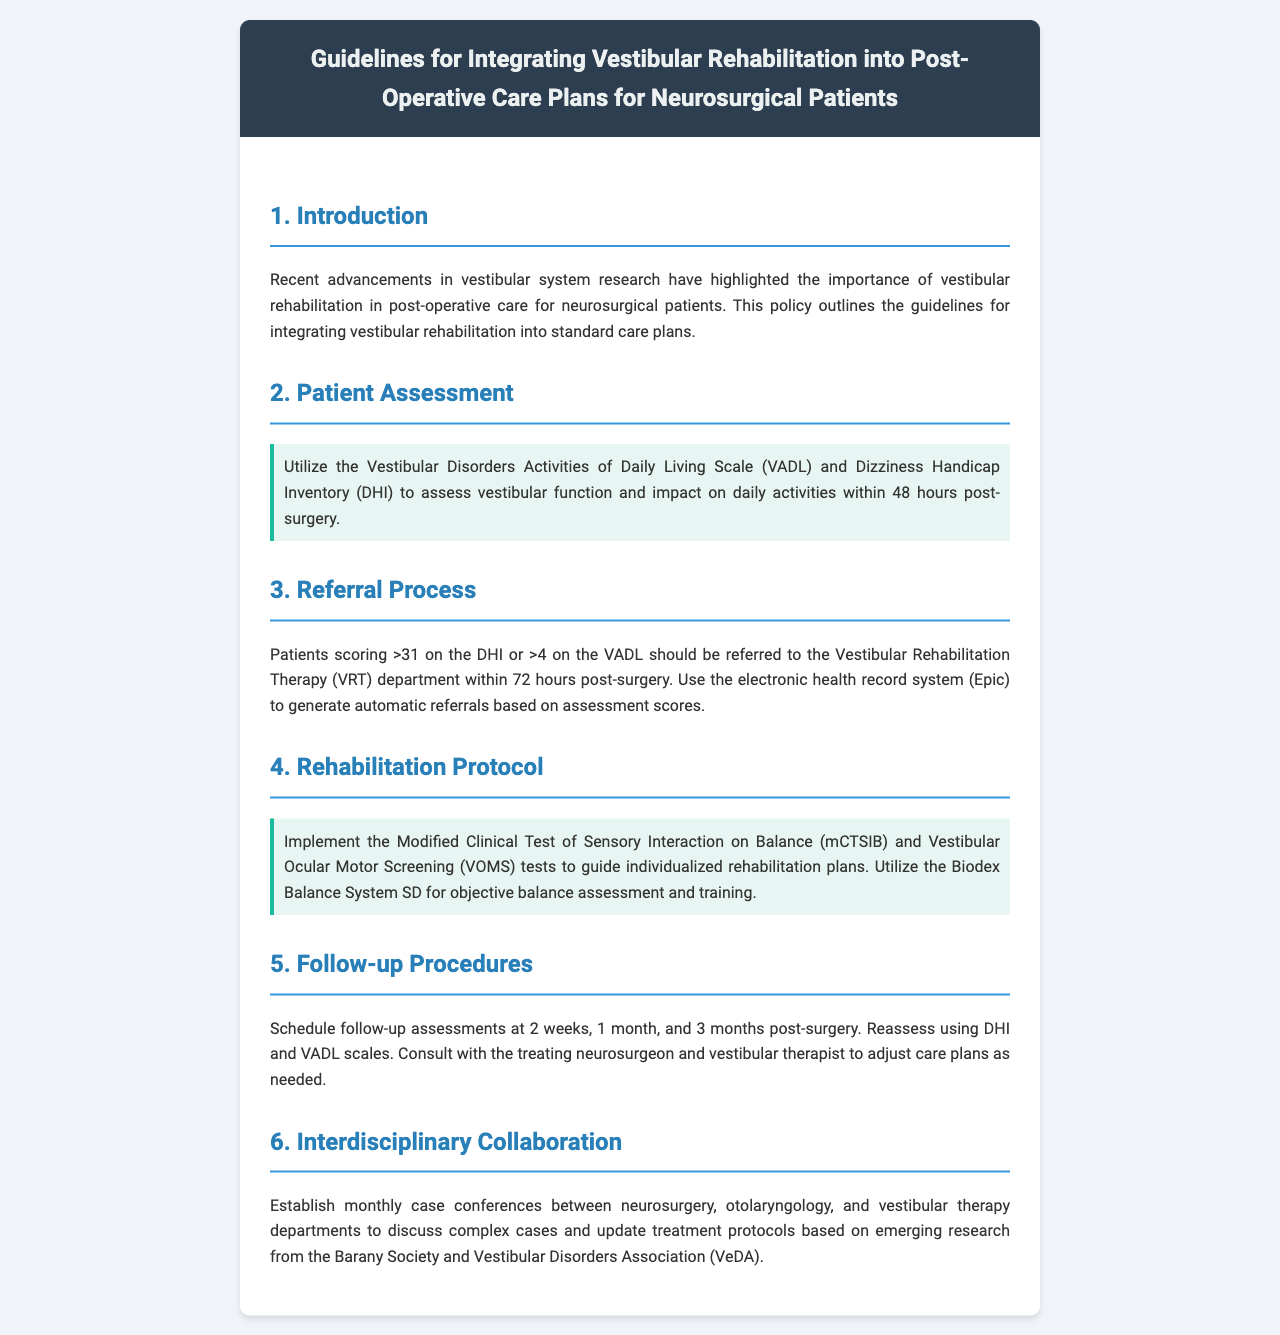What is the title of the document? The title is found at the header of the document, clearly stated in bold letters.
Answer: Guidelines for Integrating Vestibular Rehabilitation into Post-Operative Care Plans for Neurosurgical Patients What scale is used to assess vestibular function? The document specifies the use of particular scales for assessment, highlighting them in a dedicated section.
Answer: Vestibular Disorders Activities of Daily Living Scale (VADL) What DHI score prompts a referral to VRT? A specific score threshold for referral is provided in the referral process section of the document.
Answer: >31 What is the follow-up assessment schedule? The document outlines specific timeframes for follow-up assessments related to post-surgery care in a clear sequence.
Answer: 2 weeks, 1 month, and 3 months Which test is mentioned for balance assessment? A test specifically designed for balance assessment is highlighted in the rehabilitation protocol section of the document.
Answer: Modified Clinical Test of Sensory Interaction on Balance (mCTSIB) How often are case conferences held? The document mentions the frequency of interdisciplinary case conferences, which indicates collaboration among various departments.
Answer: Monthly What is the maximum time for referral post-surgery? The referral process explains the timeframe allowed for making referrals after surgery, outlined in a clear and concise manner.
Answer: 72 hours 